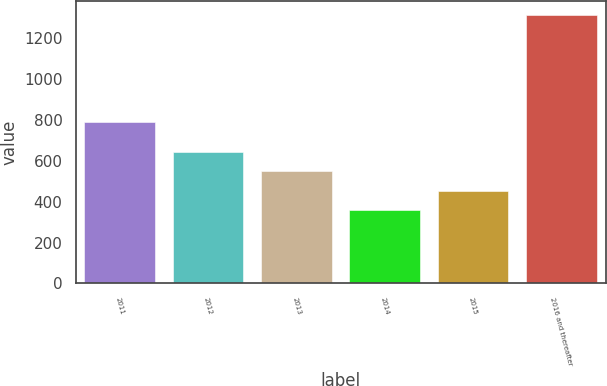<chart> <loc_0><loc_0><loc_500><loc_500><bar_chart><fcel>2011<fcel>2012<fcel>2013<fcel>2014<fcel>2015<fcel>2016 and thereafter<nl><fcel>793<fcel>646.1<fcel>550.4<fcel>359<fcel>454.7<fcel>1316<nl></chart> 